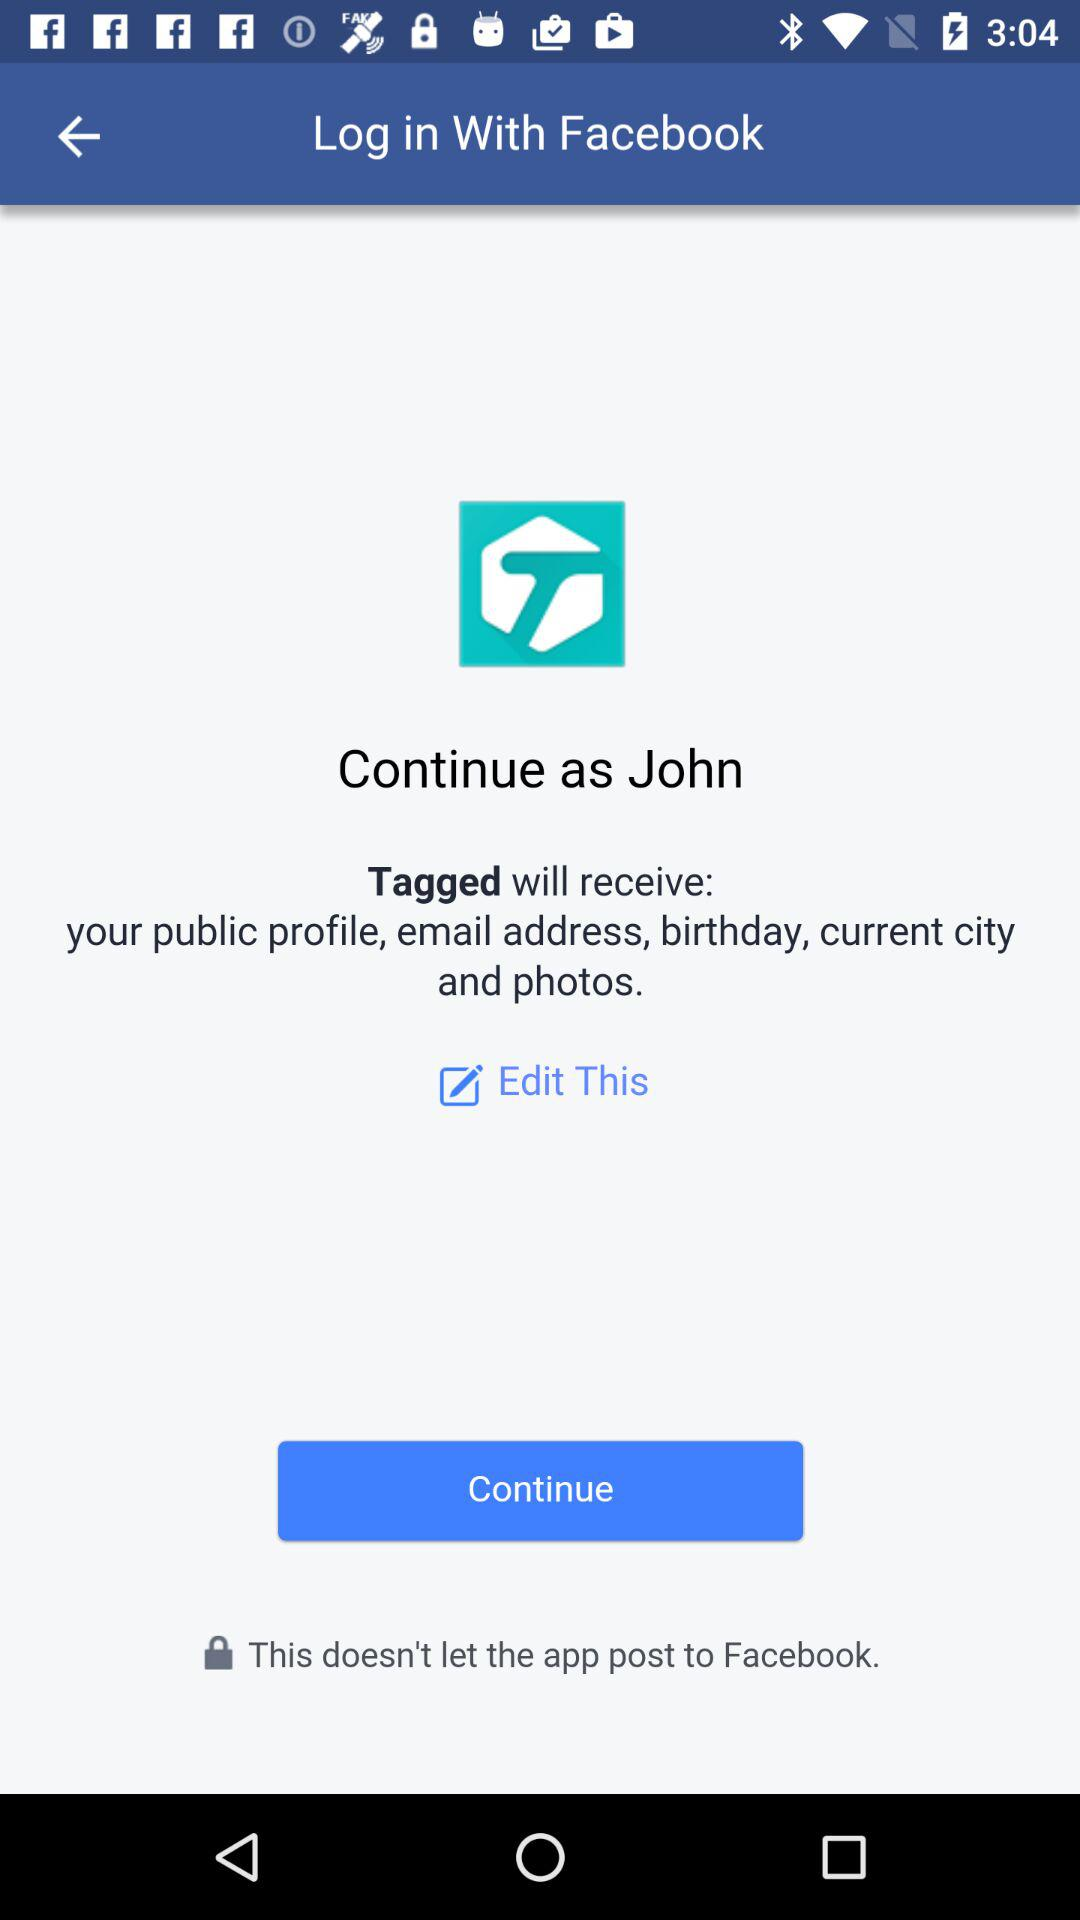What is the login name? The login name is John. 